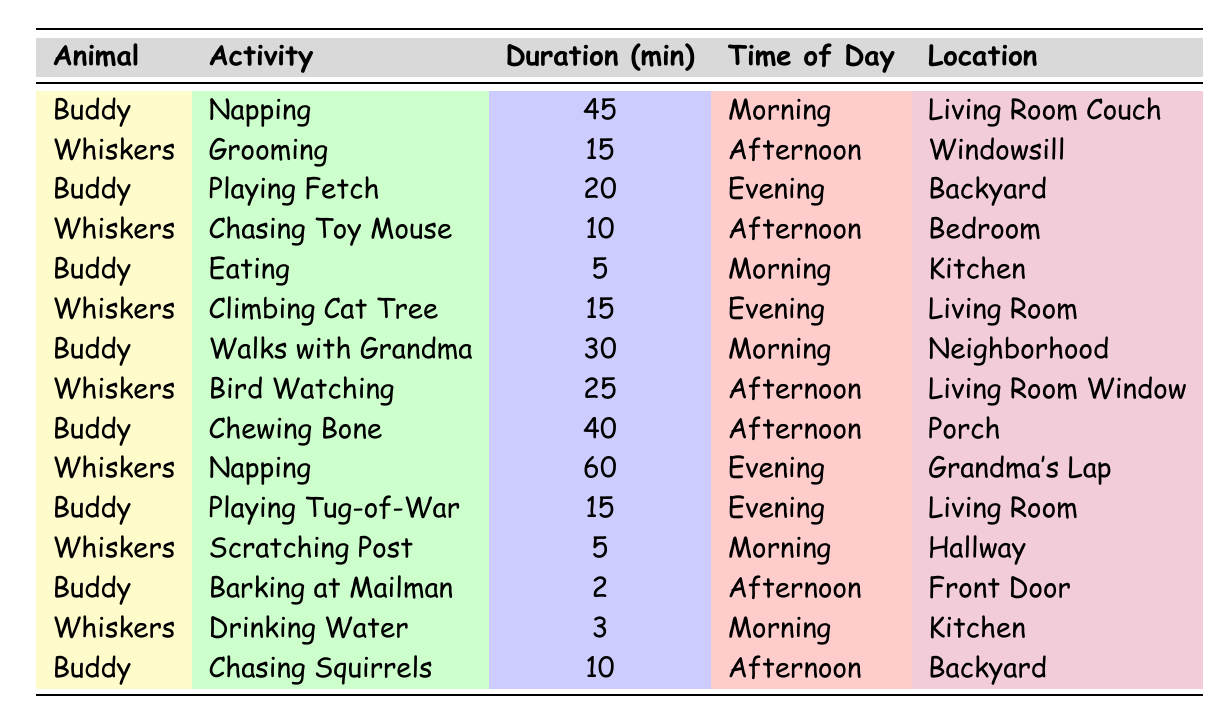What activities does Buddy do in the morning? According to the table, Buddy has three activities listed in the morning: Napping for 45 minutes, Eating for 5 minutes, and Walks with Grandma for 30 minutes.
Answer: Napping, Eating, Walks with Grandma How long does Whiskers spend on grooming and climbing the cat tree combined? Whiskers spends 15 minutes on grooming and 15 minutes on climbing the cat tree. Combining these, the total time is 15 + 15 = 30 minutes.
Answer: 30 minutes Does Buddy ever bark at the mailman? Yes, the table indicates that Buddy barks at the mailman for 2 minutes in the afternoon.
Answer: Yes What is the total time Buddy spends on activities in the evening? In the evening, Buddy has three activities: Playing Fetch for 20 minutes, Playing Tug-of-War for 15 minutes, and Chewing Bone for 40 minutes. Adding these together gives us 20 + 15 + 40 = 75 minutes.
Answer: 75 minutes Which animal spends the most time napping, and how long do they nap? Whiskers spends 60 minutes napping in the evening, which is longer than Buddy's 45 minutes of napping in the morning. Therefore, Whiskers spends the most time napping.
Answer: Whiskers, 60 minutes What activities does Whiskers do in the afternoon? In the afternoon, Whiskers is engaged in Grooming for 15 minutes and Bird Watching for 25 minutes, totaling these gives us two activities in the afternoon.
Answer: Grooming, Bird Watching How many times does Buddy engage in playing activities? Buddy participates in three playing activities: Playing Fetch for 20 minutes, Playing Tug-of-War for 15 minutes, and he is also involved in Chasing Squirrels for 10 minutes in the afternoon. Therefore, these playing activities add up to three instances.
Answer: Three times What is the average duration of Buddy's activities? Buddy has the following activities: Napping (45 min), Playing Fetch (20 min), Eating (5 min), Walks with Grandma (30 min), Chewing Bone (40 min), Playing Tug-of-War (15 min), Barking at Mailman (2 min), and Chasing Squirrels (10 min). The total duration is 45+20+5+30+40+15+2+10 = 167 minutes, divided by 8 activities gives us an average of 167/8 = 20.875.
Answer: 20.875 minutes Which animal spends more time playing in the backyard? Buddy plays Fetch for 20 minutes and Chasing Squirrels for 10 minutes, totaling 30 minutes in the backyard. Whiskers does not have any activities listed for the backyard, hence Buddy spends more time playing there.
Answer: Buddy How does Buddy's total activity duration compare to Whiskers'? Buddy's total activity duration is 167 minutes, while Whiskers' total activity duration is 85 minutes (15+10+25+60+15+5+3). Therefore, Buddy's activity time is greater than Whiskers'.
Answer: Buddy spends more time 